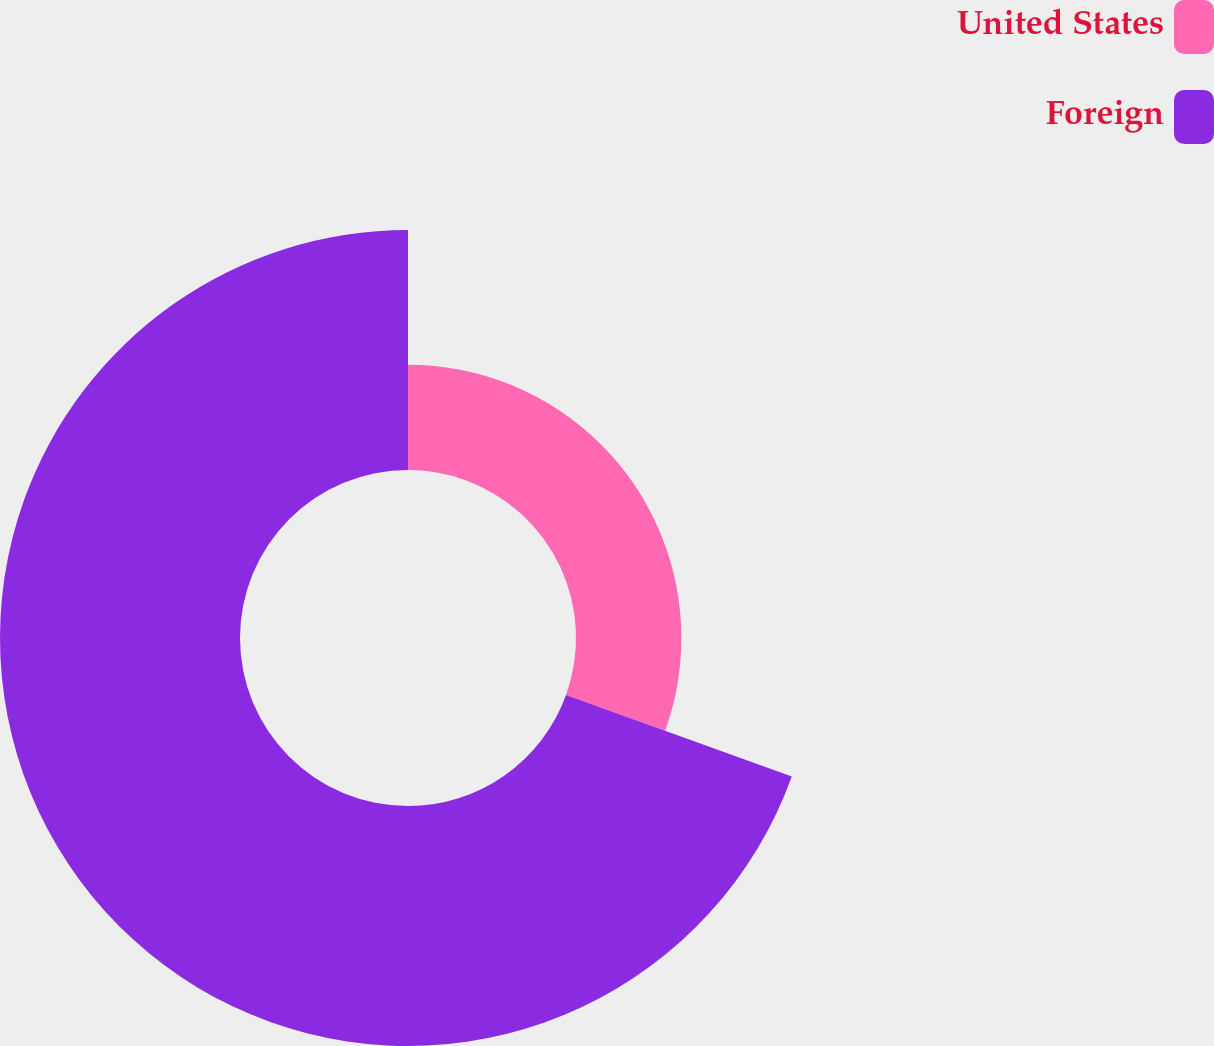Convert chart to OTSL. <chart><loc_0><loc_0><loc_500><loc_500><pie_chart><fcel>United States<fcel>Foreign<nl><fcel>30.51%<fcel>69.49%<nl></chart> 